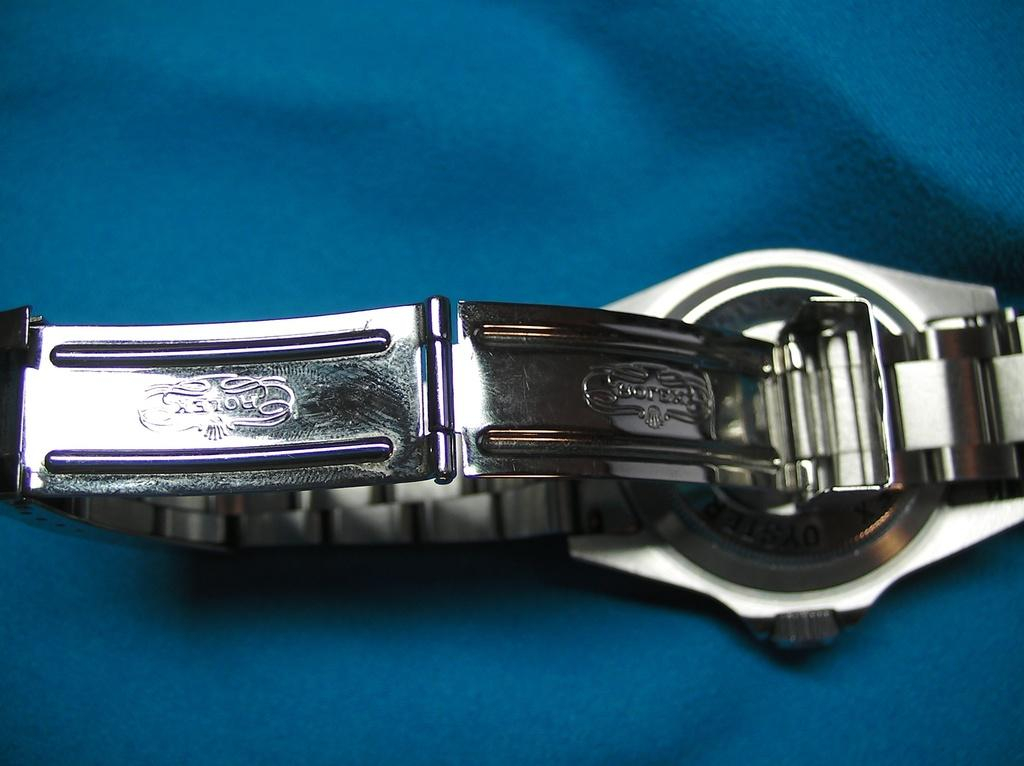<image>
Relay a brief, clear account of the picture shown. A watch is upside down with the band nme Rolex showing 